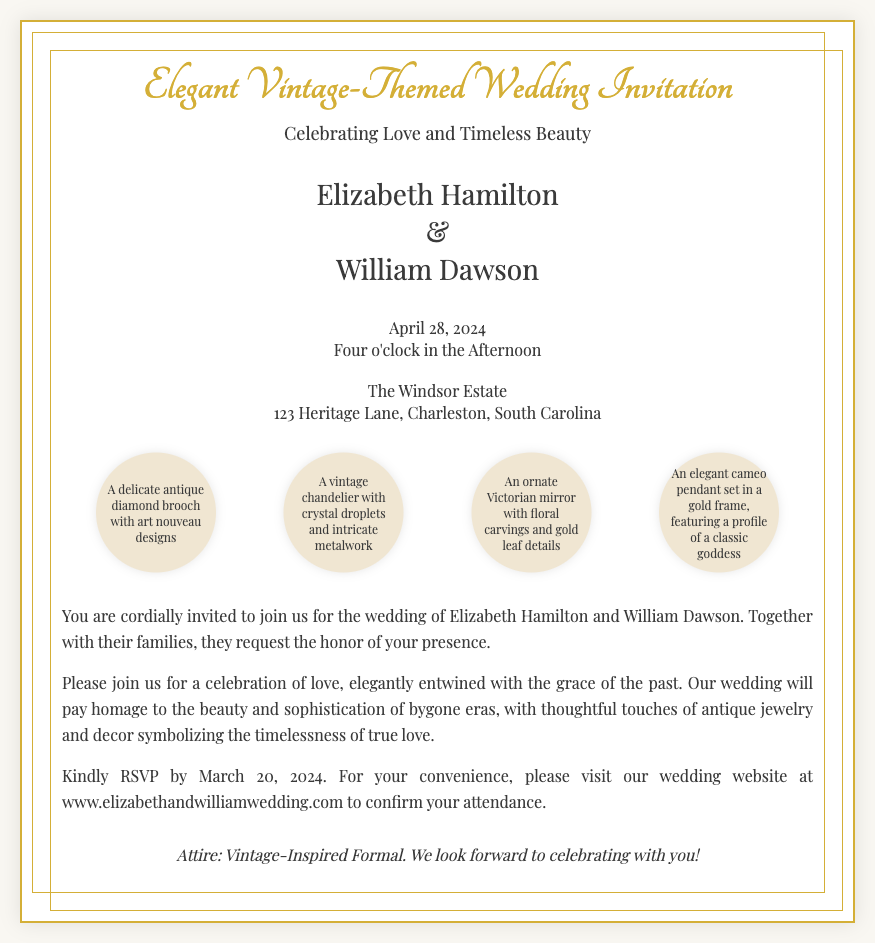What are the names of the couple? The invitation clearly states the names of the couple getting married: Elizabeth Hamilton and William Dawson.
Answer: Elizabeth Hamilton and William Dawson What is the wedding date? The invitation provides the specific date for the wedding as April 28, 2024.
Answer: April 28, 2024 What time does the wedding ceremony start? The document mentions that the ceremony will be held at four o'clock in the afternoon.
Answer: Four o'clock in the Afternoon Where is the wedding venue located? The invitation specifies the location of the wedding as The Windsor Estate, 123 Heritage Lane, Charleston, South Carolina.
Answer: The Windsor Estate, 123 Heritage Lane, Charleston, South Carolina What is the dress code for the wedding? The footer of the invitation indicates the attire expected for the event as Vintage-Inspired Formal.
Answer: Vintage-Inspired Formal What type of jewelry is illustrated on the invitation? The illustrations include various antique jewelry items, particularly highlighting an antique diamond brooch among others.
Answer: Antique diamond brooch How should guests RSVP? The invitation instructs guests to RSVP by visiting the wedding website provided in the text.
Answer: Wedding website What is the theme of the wedding? The title and text of the invitation emphasize that the wedding has an Elegant Vintage theme.
Answer: Elegant Vintage-Themed 